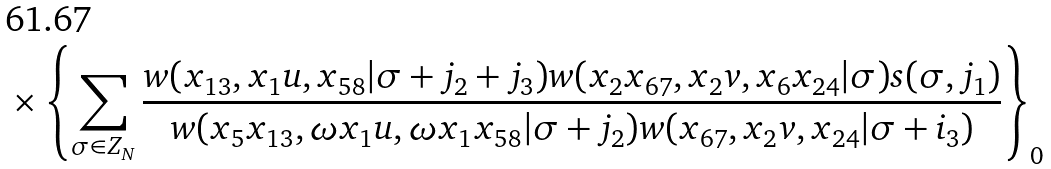<formula> <loc_0><loc_0><loc_500><loc_500>{ } \times \left \{ \sum _ { \sigma \in Z _ { N } } \frac { w ( x _ { 1 3 } , x _ { 1 } u , x _ { 5 8 } | \sigma + j _ { 2 } + j _ { 3 } ) w ( x _ { 2 } x _ { 6 7 } , x _ { 2 } v , x _ { 6 } x _ { 2 4 } | \sigma ) s ( \sigma , j _ { 1 } ) } { w ( x _ { 5 } x _ { 1 3 } , \omega x _ { 1 } u , \omega x _ { 1 } x _ { 5 8 } | \sigma + j _ { 2 } ) w ( x _ { 6 7 } , x _ { 2 } v , x _ { 2 4 } | \sigma + i _ { 3 } ) } \right \} _ { 0 }</formula> 